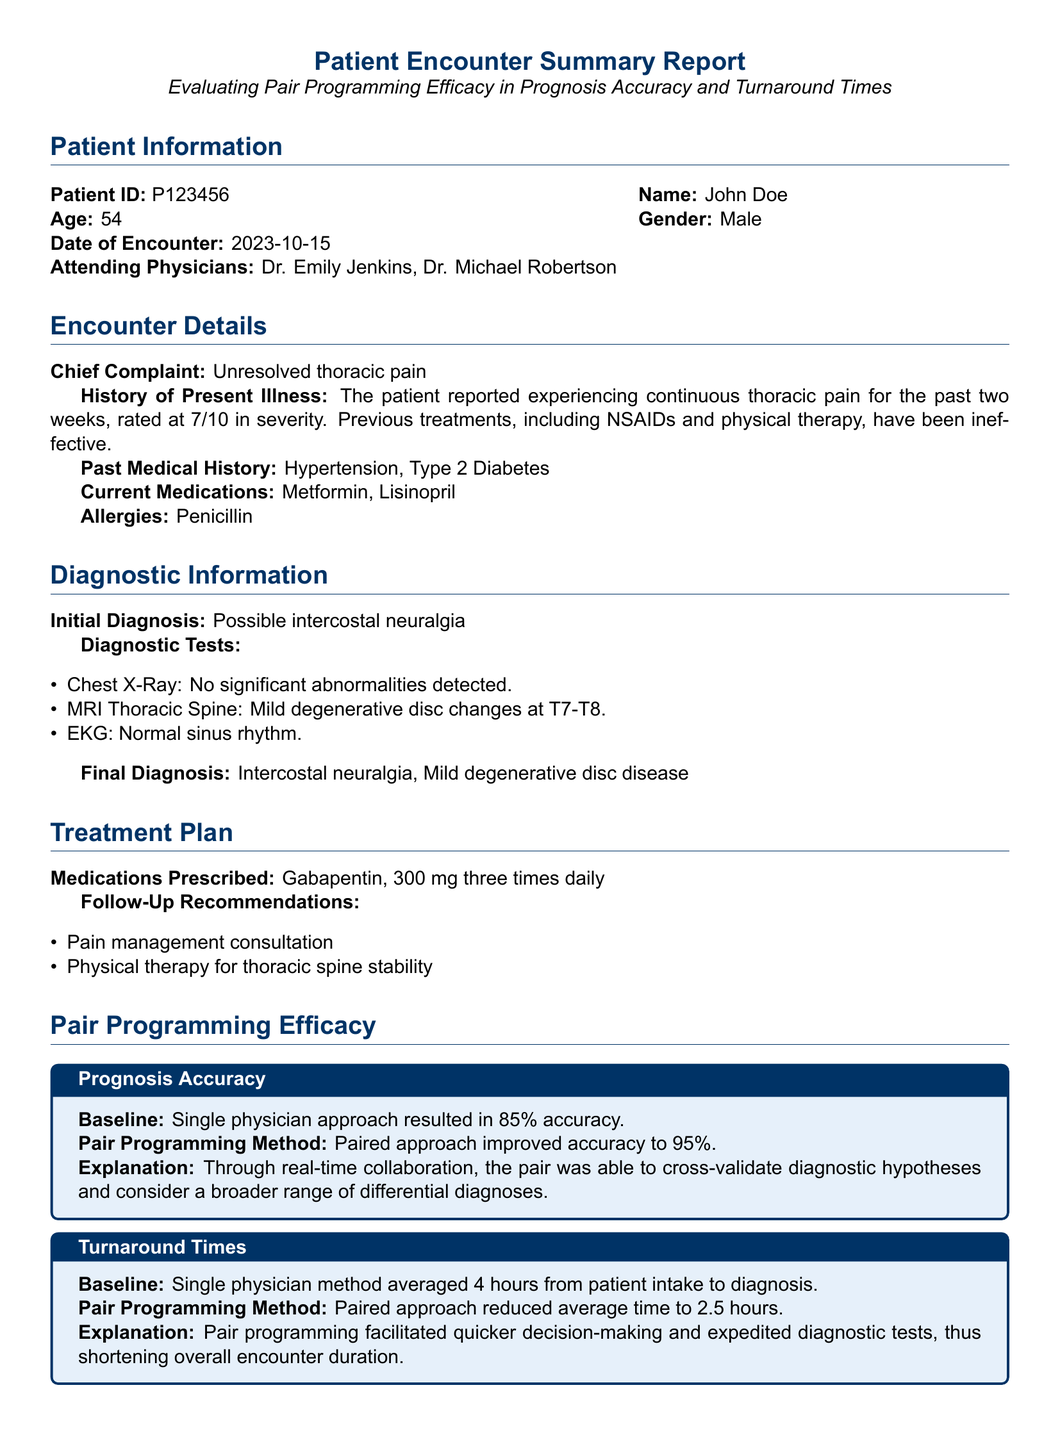What is the patient ID? The patient ID is listed in the patient information section of the document.
Answer: P123456 Who are the attending physicians? The names of the attending physicians are found in the patient information section.
Answer: Dr. Emily Jenkins, Dr. Michael Robertson What is the chief complaint of the patient? The chief complaint is detailed in the encounter details section of the document.
Answer: Unresolved thoracic pain What was the baseline accuracy from the single physician approach? The baseline accuracy is provided under the prognosis accuracy section of the document.
Answer: 85% What did the pair programming method improve the accuracy to? This information can be found in the prognosis accuracy section of the document.
Answer: 95% What was the average turnaround time with the single physician method? This detail is included in the turnaround times section of the document.
Answer: 4 hours What is the primary medication prescribed to the patient? The medication prescribed is mentioned in the treatment plan section of the document.
Answer: Gabapentin What was one of the follow-up recommendations? The follow-up recommendations are listed in the treatment plan section.
Answer: Pain management consultation How much time did pair programming reduce the average turnaround time to? The reduced turnaround time is found in the turnaround times section of the document.
Answer: 2.5 hours 